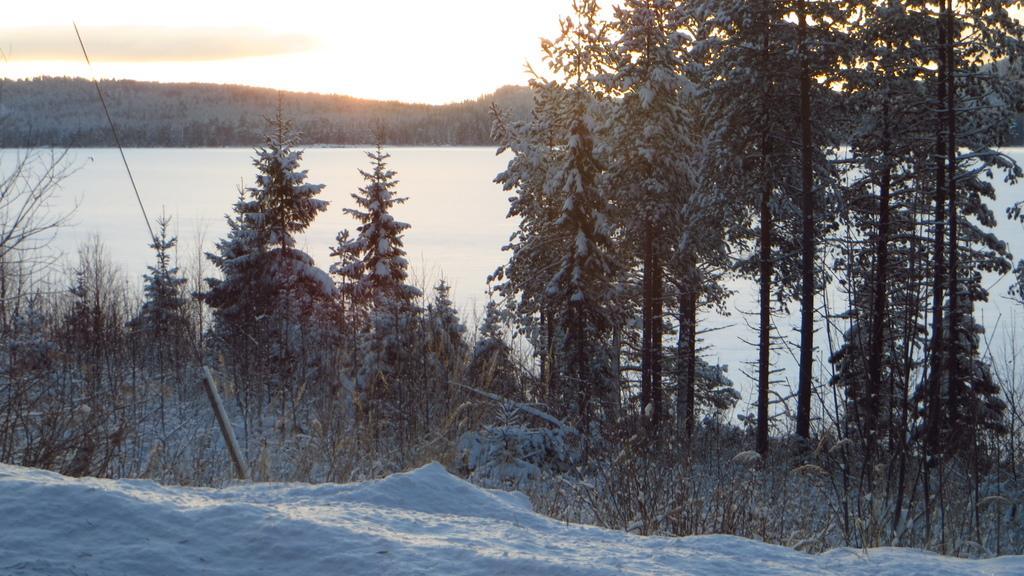Can you describe this image briefly? In this image there is snow and we can see trees covered by snow. In the background there is sky. 